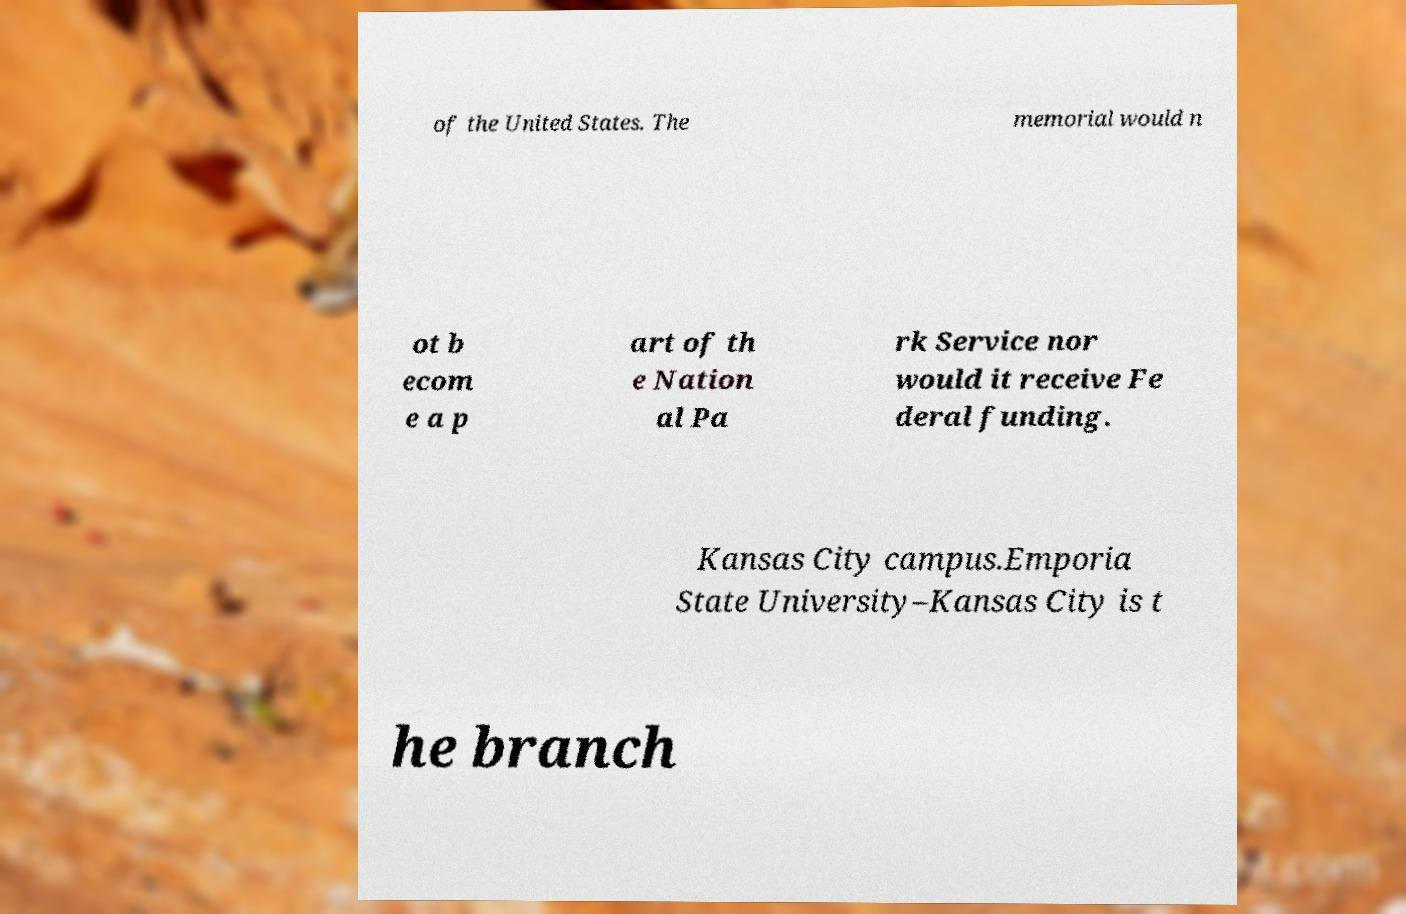Could you extract and type out the text from this image? of the United States. The memorial would n ot b ecom e a p art of th e Nation al Pa rk Service nor would it receive Fe deral funding. Kansas City campus.Emporia State University–Kansas City is t he branch 